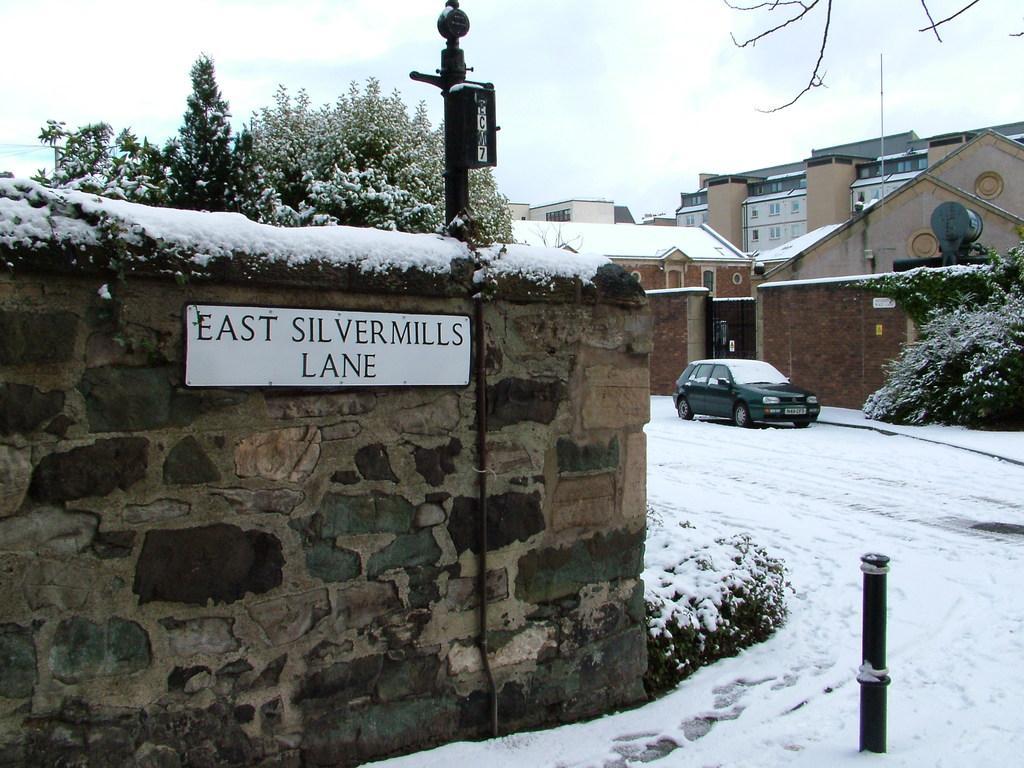Describe this image in one or two sentences. In this image I can see a white color board attached to the wall, background I can see trees covered with snow, a car in green color, few buildings in brown and cream color and the sky is in white color. 